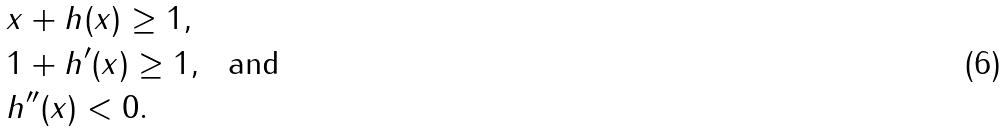Convert formula to latex. <formula><loc_0><loc_0><loc_500><loc_500>& x + h ( x ) \geq 1 , \\ & 1 + h ^ { \prime } ( x ) \geq 1 , \ \text { and} \\ & h ^ { \prime \prime } ( x ) < 0 .</formula> 